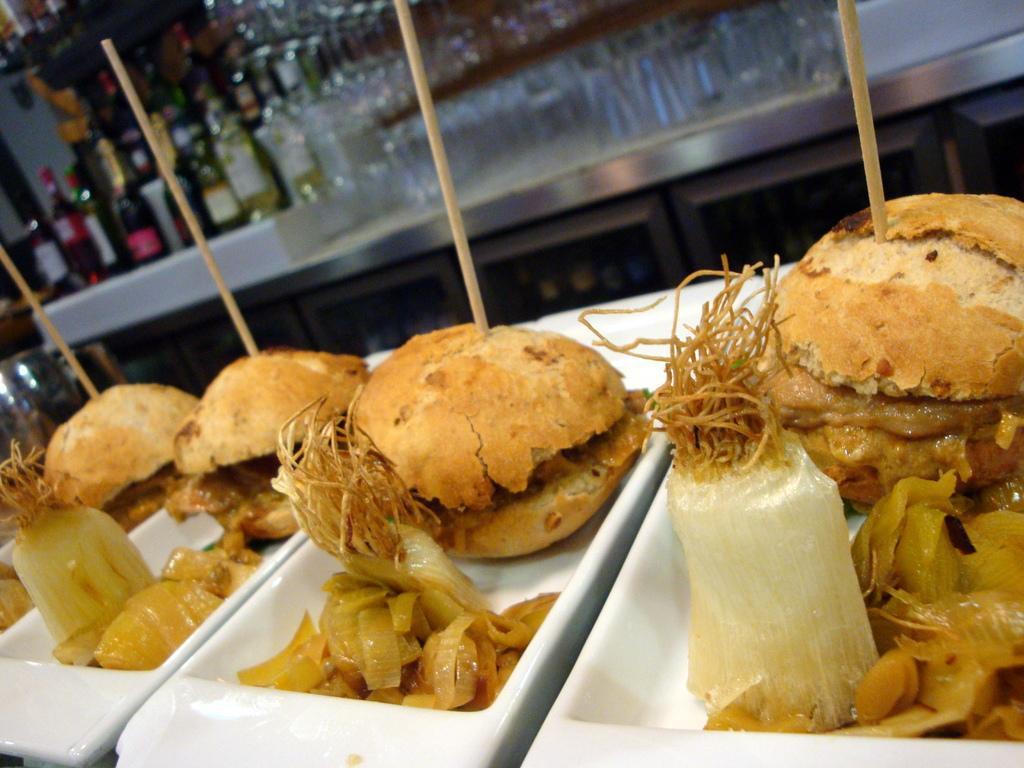Describe this image in one or two sentences. On these white plates there are burgers and food. Background it is blur. On this table there are bottles and glasses. On these burgers there are sticks. 